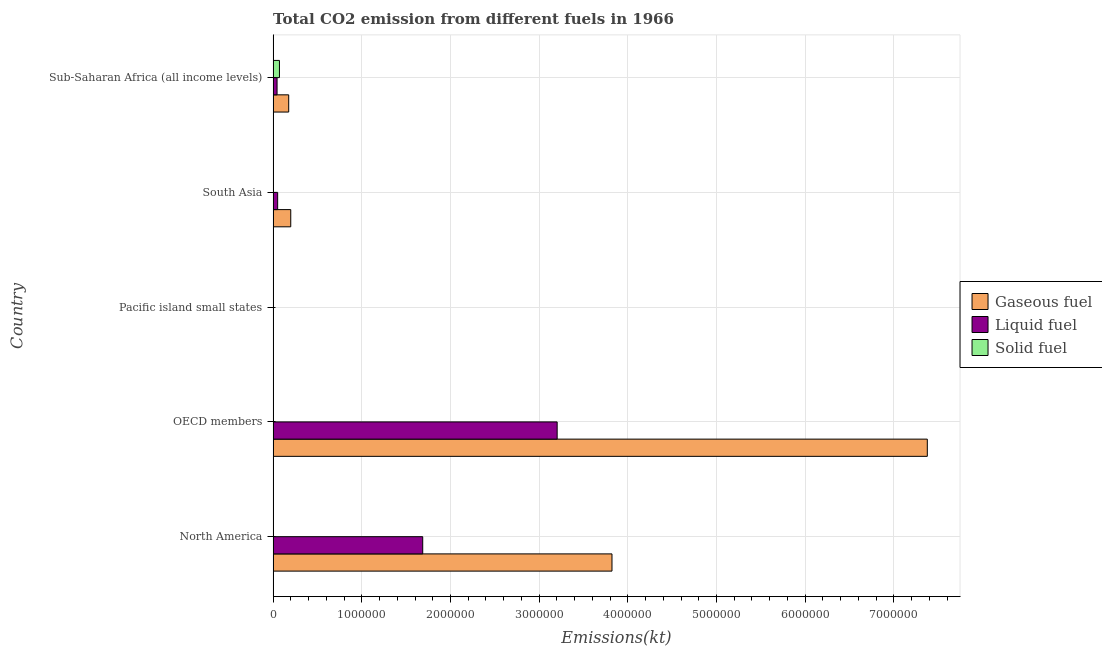Are the number of bars per tick equal to the number of legend labels?
Your answer should be compact. Yes. How many bars are there on the 1st tick from the top?
Keep it short and to the point. 3. How many bars are there on the 3rd tick from the bottom?
Offer a terse response. 3. In how many cases, is the number of bars for a given country not equal to the number of legend labels?
Make the answer very short. 0. What is the amount of co2 emissions from gaseous fuel in Pacific island small states?
Your answer should be compact. 590.17. Across all countries, what is the maximum amount of co2 emissions from solid fuel?
Your answer should be compact. 7.15e+04. Across all countries, what is the minimum amount of co2 emissions from gaseous fuel?
Keep it short and to the point. 590.17. In which country was the amount of co2 emissions from solid fuel maximum?
Offer a terse response. Sub-Saharan Africa (all income levels). In which country was the amount of co2 emissions from gaseous fuel minimum?
Your response must be concise. Pacific island small states. What is the total amount of co2 emissions from liquid fuel in the graph?
Provide a succinct answer. 4.99e+06. What is the difference between the amount of co2 emissions from gaseous fuel in Pacific island small states and that in South Asia?
Your answer should be very brief. -1.98e+05. What is the difference between the amount of co2 emissions from liquid fuel in South Asia and the amount of co2 emissions from solid fuel in North America?
Your answer should be very brief. 5.07e+04. What is the average amount of co2 emissions from solid fuel per country?
Provide a short and direct response. 1.50e+04. What is the difference between the amount of co2 emissions from gaseous fuel and amount of co2 emissions from solid fuel in Sub-Saharan Africa (all income levels)?
Ensure brevity in your answer.  1.04e+05. In how many countries, is the amount of co2 emissions from solid fuel greater than 4600000 kt?
Provide a short and direct response. 0. What is the ratio of the amount of co2 emissions from liquid fuel in North America to that in OECD members?
Offer a terse response. 0.53. Is the amount of co2 emissions from gaseous fuel in OECD members less than that in South Asia?
Provide a succinct answer. No. What is the difference between the highest and the second highest amount of co2 emissions from solid fuel?
Your answer should be compact. 6.89e+04. What is the difference between the highest and the lowest amount of co2 emissions from solid fuel?
Provide a succinct answer. 7.14e+04. Is the sum of the amount of co2 emissions from solid fuel in Pacific island small states and South Asia greater than the maximum amount of co2 emissions from liquid fuel across all countries?
Your answer should be very brief. No. What does the 3rd bar from the top in South Asia represents?
Make the answer very short. Gaseous fuel. What does the 2nd bar from the bottom in OECD members represents?
Make the answer very short. Liquid fuel. How many bars are there?
Give a very brief answer. 15. Are all the bars in the graph horizontal?
Your response must be concise. Yes. How many countries are there in the graph?
Provide a short and direct response. 5. Where does the legend appear in the graph?
Give a very brief answer. Center right. How are the legend labels stacked?
Your response must be concise. Vertical. What is the title of the graph?
Your response must be concise. Total CO2 emission from different fuels in 1966. Does "Food" appear as one of the legend labels in the graph?
Offer a very short reply. No. What is the label or title of the X-axis?
Give a very brief answer. Emissions(kt). What is the label or title of the Y-axis?
Give a very brief answer. Country. What is the Emissions(kt) in Gaseous fuel in North America?
Provide a succinct answer. 3.82e+06. What is the Emissions(kt) in Liquid fuel in North America?
Offer a terse response. 1.69e+06. What is the Emissions(kt) of Solid fuel in North America?
Provide a short and direct response. 476.71. What is the Emissions(kt) of Gaseous fuel in OECD members?
Offer a terse response. 7.38e+06. What is the Emissions(kt) in Liquid fuel in OECD members?
Make the answer very short. 3.20e+06. What is the Emissions(kt) in Solid fuel in OECD members?
Keep it short and to the point. 271.36. What is the Emissions(kt) of Gaseous fuel in Pacific island small states?
Your answer should be compact. 590.17. What is the Emissions(kt) in Liquid fuel in Pacific island small states?
Provide a succinct answer. 517.2. What is the Emissions(kt) of Solid fuel in Pacific island small states?
Provide a short and direct response. 88.01. What is the Emissions(kt) of Gaseous fuel in South Asia?
Your answer should be compact. 1.99e+05. What is the Emissions(kt) in Liquid fuel in South Asia?
Provide a short and direct response. 5.11e+04. What is the Emissions(kt) of Solid fuel in South Asia?
Your answer should be compact. 2588.9. What is the Emissions(kt) in Gaseous fuel in Sub-Saharan Africa (all income levels)?
Your answer should be compact. 1.76e+05. What is the Emissions(kt) of Liquid fuel in Sub-Saharan Africa (all income levels)?
Your response must be concise. 4.44e+04. What is the Emissions(kt) of Solid fuel in Sub-Saharan Africa (all income levels)?
Keep it short and to the point. 7.15e+04. Across all countries, what is the maximum Emissions(kt) in Gaseous fuel?
Provide a short and direct response. 7.38e+06. Across all countries, what is the maximum Emissions(kt) in Liquid fuel?
Your answer should be very brief. 3.20e+06. Across all countries, what is the maximum Emissions(kt) in Solid fuel?
Provide a succinct answer. 7.15e+04. Across all countries, what is the minimum Emissions(kt) of Gaseous fuel?
Your response must be concise. 590.17. Across all countries, what is the minimum Emissions(kt) in Liquid fuel?
Your answer should be compact. 517.2. Across all countries, what is the minimum Emissions(kt) of Solid fuel?
Offer a terse response. 88.01. What is the total Emissions(kt) in Gaseous fuel in the graph?
Your answer should be very brief. 1.16e+07. What is the total Emissions(kt) in Liquid fuel in the graph?
Provide a succinct answer. 4.99e+06. What is the total Emissions(kt) of Solid fuel in the graph?
Ensure brevity in your answer.  7.49e+04. What is the difference between the Emissions(kt) of Gaseous fuel in North America and that in OECD members?
Your answer should be compact. -3.56e+06. What is the difference between the Emissions(kt) in Liquid fuel in North America and that in OECD members?
Your answer should be compact. -1.52e+06. What is the difference between the Emissions(kt) in Solid fuel in North America and that in OECD members?
Offer a very short reply. 205.35. What is the difference between the Emissions(kt) in Gaseous fuel in North America and that in Pacific island small states?
Your answer should be compact. 3.82e+06. What is the difference between the Emissions(kt) in Liquid fuel in North America and that in Pacific island small states?
Make the answer very short. 1.69e+06. What is the difference between the Emissions(kt) of Solid fuel in North America and that in Pacific island small states?
Give a very brief answer. 388.7. What is the difference between the Emissions(kt) of Gaseous fuel in North America and that in South Asia?
Provide a short and direct response. 3.62e+06. What is the difference between the Emissions(kt) in Liquid fuel in North America and that in South Asia?
Offer a very short reply. 1.64e+06. What is the difference between the Emissions(kt) in Solid fuel in North America and that in South Asia?
Give a very brief answer. -2112.19. What is the difference between the Emissions(kt) of Gaseous fuel in North America and that in Sub-Saharan Africa (all income levels)?
Your answer should be compact. 3.65e+06. What is the difference between the Emissions(kt) of Liquid fuel in North America and that in Sub-Saharan Africa (all income levels)?
Ensure brevity in your answer.  1.64e+06. What is the difference between the Emissions(kt) in Solid fuel in North America and that in Sub-Saharan Africa (all income levels)?
Offer a very short reply. -7.10e+04. What is the difference between the Emissions(kt) in Gaseous fuel in OECD members and that in Pacific island small states?
Your answer should be very brief. 7.38e+06. What is the difference between the Emissions(kt) of Liquid fuel in OECD members and that in Pacific island small states?
Your answer should be very brief. 3.20e+06. What is the difference between the Emissions(kt) in Solid fuel in OECD members and that in Pacific island small states?
Offer a terse response. 183.35. What is the difference between the Emissions(kt) in Gaseous fuel in OECD members and that in South Asia?
Provide a short and direct response. 7.18e+06. What is the difference between the Emissions(kt) of Liquid fuel in OECD members and that in South Asia?
Your response must be concise. 3.15e+06. What is the difference between the Emissions(kt) of Solid fuel in OECD members and that in South Asia?
Provide a succinct answer. -2317.54. What is the difference between the Emissions(kt) of Gaseous fuel in OECD members and that in Sub-Saharan Africa (all income levels)?
Your response must be concise. 7.20e+06. What is the difference between the Emissions(kt) in Liquid fuel in OECD members and that in Sub-Saharan Africa (all income levels)?
Keep it short and to the point. 3.16e+06. What is the difference between the Emissions(kt) of Solid fuel in OECD members and that in Sub-Saharan Africa (all income levels)?
Offer a very short reply. -7.12e+04. What is the difference between the Emissions(kt) in Gaseous fuel in Pacific island small states and that in South Asia?
Provide a short and direct response. -1.98e+05. What is the difference between the Emissions(kt) in Liquid fuel in Pacific island small states and that in South Asia?
Offer a terse response. -5.06e+04. What is the difference between the Emissions(kt) of Solid fuel in Pacific island small states and that in South Asia?
Your answer should be very brief. -2500.89. What is the difference between the Emissions(kt) in Gaseous fuel in Pacific island small states and that in Sub-Saharan Africa (all income levels)?
Provide a short and direct response. -1.75e+05. What is the difference between the Emissions(kt) in Liquid fuel in Pacific island small states and that in Sub-Saharan Africa (all income levels)?
Provide a short and direct response. -4.39e+04. What is the difference between the Emissions(kt) in Solid fuel in Pacific island small states and that in Sub-Saharan Africa (all income levels)?
Ensure brevity in your answer.  -7.14e+04. What is the difference between the Emissions(kt) in Gaseous fuel in South Asia and that in Sub-Saharan Africa (all income levels)?
Your answer should be compact. 2.32e+04. What is the difference between the Emissions(kt) in Liquid fuel in South Asia and that in Sub-Saharan Africa (all income levels)?
Offer a very short reply. 6718.26. What is the difference between the Emissions(kt) of Solid fuel in South Asia and that in Sub-Saharan Africa (all income levels)?
Make the answer very short. -6.89e+04. What is the difference between the Emissions(kt) in Gaseous fuel in North America and the Emissions(kt) in Liquid fuel in OECD members?
Offer a terse response. 6.18e+05. What is the difference between the Emissions(kt) of Gaseous fuel in North America and the Emissions(kt) of Solid fuel in OECD members?
Your answer should be compact. 3.82e+06. What is the difference between the Emissions(kt) of Liquid fuel in North America and the Emissions(kt) of Solid fuel in OECD members?
Ensure brevity in your answer.  1.69e+06. What is the difference between the Emissions(kt) of Gaseous fuel in North America and the Emissions(kt) of Liquid fuel in Pacific island small states?
Provide a short and direct response. 3.82e+06. What is the difference between the Emissions(kt) in Gaseous fuel in North America and the Emissions(kt) in Solid fuel in Pacific island small states?
Offer a terse response. 3.82e+06. What is the difference between the Emissions(kt) of Liquid fuel in North America and the Emissions(kt) of Solid fuel in Pacific island small states?
Offer a very short reply. 1.69e+06. What is the difference between the Emissions(kt) in Gaseous fuel in North America and the Emissions(kt) in Liquid fuel in South Asia?
Keep it short and to the point. 3.77e+06. What is the difference between the Emissions(kt) of Gaseous fuel in North America and the Emissions(kt) of Solid fuel in South Asia?
Offer a very short reply. 3.82e+06. What is the difference between the Emissions(kt) of Liquid fuel in North America and the Emissions(kt) of Solid fuel in South Asia?
Provide a short and direct response. 1.68e+06. What is the difference between the Emissions(kt) in Gaseous fuel in North America and the Emissions(kt) in Liquid fuel in Sub-Saharan Africa (all income levels)?
Your answer should be compact. 3.78e+06. What is the difference between the Emissions(kt) of Gaseous fuel in North America and the Emissions(kt) of Solid fuel in Sub-Saharan Africa (all income levels)?
Provide a succinct answer. 3.75e+06. What is the difference between the Emissions(kt) of Liquid fuel in North America and the Emissions(kt) of Solid fuel in Sub-Saharan Africa (all income levels)?
Give a very brief answer. 1.62e+06. What is the difference between the Emissions(kt) of Gaseous fuel in OECD members and the Emissions(kt) of Liquid fuel in Pacific island small states?
Keep it short and to the point. 7.38e+06. What is the difference between the Emissions(kt) in Gaseous fuel in OECD members and the Emissions(kt) in Solid fuel in Pacific island small states?
Offer a very short reply. 7.38e+06. What is the difference between the Emissions(kt) of Liquid fuel in OECD members and the Emissions(kt) of Solid fuel in Pacific island small states?
Offer a terse response. 3.20e+06. What is the difference between the Emissions(kt) in Gaseous fuel in OECD members and the Emissions(kt) in Liquid fuel in South Asia?
Ensure brevity in your answer.  7.33e+06. What is the difference between the Emissions(kt) of Gaseous fuel in OECD members and the Emissions(kt) of Solid fuel in South Asia?
Offer a terse response. 7.37e+06. What is the difference between the Emissions(kt) of Liquid fuel in OECD members and the Emissions(kt) of Solid fuel in South Asia?
Make the answer very short. 3.20e+06. What is the difference between the Emissions(kt) in Gaseous fuel in OECD members and the Emissions(kt) in Liquid fuel in Sub-Saharan Africa (all income levels)?
Offer a very short reply. 7.33e+06. What is the difference between the Emissions(kt) of Gaseous fuel in OECD members and the Emissions(kt) of Solid fuel in Sub-Saharan Africa (all income levels)?
Make the answer very short. 7.31e+06. What is the difference between the Emissions(kt) in Liquid fuel in OECD members and the Emissions(kt) in Solid fuel in Sub-Saharan Africa (all income levels)?
Your answer should be very brief. 3.13e+06. What is the difference between the Emissions(kt) in Gaseous fuel in Pacific island small states and the Emissions(kt) in Liquid fuel in South Asia?
Your answer should be compact. -5.05e+04. What is the difference between the Emissions(kt) in Gaseous fuel in Pacific island small states and the Emissions(kt) in Solid fuel in South Asia?
Your answer should be very brief. -1998.74. What is the difference between the Emissions(kt) of Liquid fuel in Pacific island small states and the Emissions(kt) of Solid fuel in South Asia?
Make the answer very short. -2071.71. What is the difference between the Emissions(kt) of Gaseous fuel in Pacific island small states and the Emissions(kt) of Liquid fuel in Sub-Saharan Africa (all income levels)?
Provide a succinct answer. -4.38e+04. What is the difference between the Emissions(kt) in Gaseous fuel in Pacific island small states and the Emissions(kt) in Solid fuel in Sub-Saharan Africa (all income levels)?
Provide a succinct answer. -7.09e+04. What is the difference between the Emissions(kt) in Liquid fuel in Pacific island small states and the Emissions(kt) in Solid fuel in Sub-Saharan Africa (all income levels)?
Give a very brief answer. -7.09e+04. What is the difference between the Emissions(kt) in Gaseous fuel in South Asia and the Emissions(kt) in Liquid fuel in Sub-Saharan Africa (all income levels)?
Provide a short and direct response. 1.54e+05. What is the difference between the Emissions(kt) in Gaseous fuel in South Asia and the Emissions(kt) in Solid fuel in Sub-Saharan Africa (all income levels)?
Give a very brief answer. 1.27e+05. What is the difference between the Emissions(kt) in Liquid fuel in South Asia and the Emissions(kt) in Solid fuel in Sub-Saharan Africa (all income levels)?
Your response must be concise. -2.03e+04. What is the average Emissions(kt) in Gaseous fuel per country?
Your answer should be very brief. 2.31e+06. What is the average Emissions(kt) in Liquid fuel per country?
Your response must be concise. 9.97e+05. What is the average Emissions(kt) of Solid fuel per country?
Provide a short and direct response. 1.50e+04. What is the difference between the Emissions(kt) of Gaseous fuel and Emissions(kt) of Liquid fuel in North America?
Ensure brevity in your answer.  2.13e+06. What is the difference between the Emissions(kt) in Gaseous fuel and Emissions(kt) in Solid fuel in North America?
Give a very brief answer. 3.82e+06. What is the difference between the Emissions(kt) of Liquid fuel and Emissions(kt) of Solid fuel in North America?
Offer a terse response. 1.69e+06. What is the difference between the Emissions(kt) of Gaseous fuel and Emissions(kt) of Liquid fuel in OECD members?
Offer a very short reply. 4.17e+06. What is the difference between the Emissions(kt) of Gaseous fuel and Emissions(kt) of Solid fuel in OECD members?
Your response must be concise. 7.38e+06. What is the difference between the Emissions(kt) in Liquid fuel and Emissions(kt) in Solid fuel in OECD members?
Your response must be concise. 3.20e+06. What is the difference between the Emissions(kt) in Gaseous fuel and Emissions(kt) in Liquid fuel in Pacific island small states?
Your answer should be compact. 72.97. What is the difference between the Emissions(kt) in Gaseous fuel and Emissions(kt) in Solid fuel in Pacific island small states?
Make the answer very short. 502.16. What is the difference between the Emissions(kt) in Liquid fuel and Emissions(kt) in Solid fuel in Pacific island small states?
Your response must be concise. 429.19. What is the difference between the Emissions(kt) in Gaseous fuel and Emissions(kt) in Liquid fuel in South Asia?
Your answer should be very brief. 1.48e+05. What is the difference between the Emissions(kt) of Gaseous fuel and Emissions(kt) of Solid fuel in South Asia?
Your answer should be very brief. 1.96e+05. What is the difference between the Emissions(kt) in Liquid fuel and Emissions(kt) in Solid fuel in South Asia?
Make the answer very short. 4.86e+04. What is the difference between the Emissions(kt) of Gaseous fuel and Emissions(kt) of Liquid fuel in Sub-Saharan Africa (all income levels)?
Ensure brevity in your answer.  1.31e+05. What is the difference between the Emissions(kt) of Gaseous fuel and Emissions(kt) of Solid fuel in Sub-Saharan Africa (all income levels)?
Your answer should be very brief. 1.04e+05. What is the difference between the Emissions(kt) of Liquid fuel and Emissions(kt) of Solid fuel in Sub-Saharan Africa (all income levels)?
Give a very brief answer. -2.70e+04. What is the ratio of the Emissions(kt) in Gaseous fuel in North America to that in OECD members?
Your answer should be compact. 0.52. What is the ratio of the Emissions(kt) of Liquid fuel in North America to that in OECD members?
Keep it short and to the point. 0.53. What is the ratio of the Emissions(kt) of Solid fuel in North America to that in OECD members?
Give a very brief answer. 1.76. What is the ratio of the Emissions(kt) in Gaseous fuel in North America to that in Pacific island small states?
Keep it short and to the point. 6475.12. What is the ratio of the Emissions(kt) in Liquid fuel in North America to that in Pacific island small states?
Your answer should be compact. 3261.95. What is the ratio of the Emissions(kt) in Solid fuel in North America to that in Pacific island small states?
Make the answer very short. 5.42. What is the ratio of the Emissions(kt) in Gaseous fuel in North America to that in South Asia?
Make the answer very short. 19.21. What is the ratio of the Emissions(kt) in Liquid fuel in North America to that in South Asia?
Your answer should be compact. 32.99. What is the ratio of the Emissions(kt) in Solid fuel in North America to that in South Asia?
Your answer should be compact. 0.18. What is the ratio of the Emissions(kt) in Gaseous fuel in North America to that in Sub-Saharan Africa (all income levels)?
Provide a short and direct response. 21.75. What is the ratio of the Emissions(kt) in Liquid fuel in North America to that in Sub-Saharan Africa (all income levels)?
Provide a short and direct response. 37.98. What is the ratio of the Emissions(kt) of Solid fuel in North America to that in Sub-Saharan Africa (all income levels)?
Provide a short and direct response. 0.01. What is the ratio of the Emissions(kt) of Gaseous fuel in OECD members to that in Pacific island small states?
Keep it short and to the point. 1.25e+04. What is the ratio of the Emissions(kt) of Liquid fuel in OECD members to that in Pacific island small states?
Ensure brevity in your answer.  6193.24. What is the ratio of the Emissions(kt) in Solid fuel in OECD members to that in Pacific island small states?
Provide a succinct answer. 3.08. What is the ratio of the Emissions(kt) of Gaseous fuel in OECD members to that in South Asia?
Make the answer very short. 37.09. What is the ratio of the Emissions(kt) in Liquid fuel in OECD members to that in South Asia?
Your response must be concise. 62.63. What is the ratio of the Emissions(kt) in Solid fuel in OECD members to that in South Asia?
Provide a short and direct response. 0.1. What is the ratio of the Emissions(kt) in Gaseous fuel in OECD members to that in Sub-Saharan Africa (all income levels)?
Provide a short and direct response. 42. What is the ratio of the Emissions(kt) of Liquid fuel in OECD members to that in Sub-Saharan Africa (all income levels)?
Make the answer very short. 72.11. What is the ratio of the Emissions(kt) in Solid fuel in OECD members to that in Sub-Saharan Africa (all income levels)?
Provide a succinct answer. 0. What is the ratio of the Emissions(kt) in Gaseous fuel in Pacific island small states to that in South Asia?
Your response must be concise. 0. What is the ratio of the Emissions(kt) of Liquid fuel in Pacific island small states to that in South Asia?
Provide a succinct answer. 0.01. What is the ratio of the Emissions(kt) in Solid fuel in Pacific island small states to that in South Asia?
Provide a short and direct response. 0.03. What is the ratio of the Emissions(kt) of Gaseous fuel in Pacific island small states to that in Sub-Saharan Africa (all income levels)?
Make the answer very short. 0. What is the ratio of the Emissions(kt) in Liquid fuel in Pacific island small states to that in Sub-Saharan Africa (all income levels)?
Provide a short and direct response. 0.01. What is the ratio of the Emissions(kt) of Solid fuel in Pacific island small states to that in Sub-Saharan Africa (all income levels)?
Your response must be concise. 0. What is the ratio of the Emissions(kt) in Gaseous fuel in South Asia to that in Sub-Saharan Africa (all income levels)?
Give a very brief answer. 1.13. What is the ratio of the Emissions(kt) of Liquid fuel in South Asia to that in Sub-Saharan Africa (all income levels)?
Keep it short and to the point. 1.15. What is the ratio of the Emissions(kt) in Solid fuel in South Asia to that in Sub-Saharan Africa (all income levels)?
Your response must be concise. 0.04. What is the difference between the highest and the second highest Emissions(kt) of Gaseous fuel?
Your answer should be very brief. 3.56e+06. What is the difference between the highest and the second highest Emissions(kt) of Liquid fuel?
Your answer should be very brief. 1.52e+06. What is the difference between the highest and the second highest Emissions(kt) of Solid fuel?
Your answer should be very brief. 6.89e+04. What is the difference between the highest and the lowest Emissions(kt) of Gaseous fuel?
Provide a succinct answer. 7.38e+06. What is the difference between the highest and the lowest Emissions(kt) in Liquid fuel?
Provide a short and direct response. 3.20e+06. What is the difference between the highest and the lowest Emissions(kt) in Solid fuel?
Give a very brief answer. 7.14e+04. 